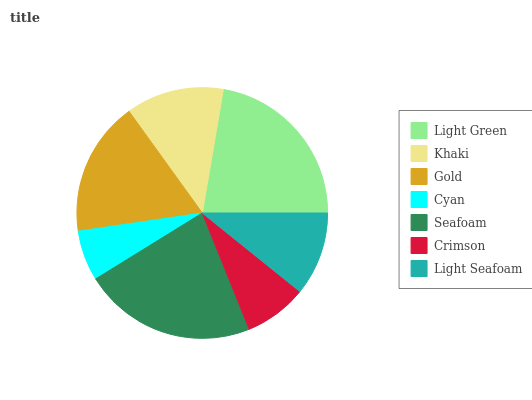Is Cyan the minimum?
Answer yes or no. Yes. Is Light Green the maximum?
Answer yes or no. Yes. Is Khaki the minimum?
Answer yes or no. No. Is Khaki the maximum?
Answer yes or no. No. Is Light Green greater than Khaki?
Answer yes or no. Yes. Is Khaki less than Light Green?
Answer yes or no. Yes. Is Khaki greater than Light Green?
Answer yes or no. No. Is Light Green less than Khaki?
Answer yes or no. No. Is Khaki the high median?
Answer yes or no. Yes. Is Khaki the low median?
Answer yes or no. Yes. Is Crimson the high median?
Answer yes or no. No. Is Light Seafoam the low median?
Answer yes or no. No. 